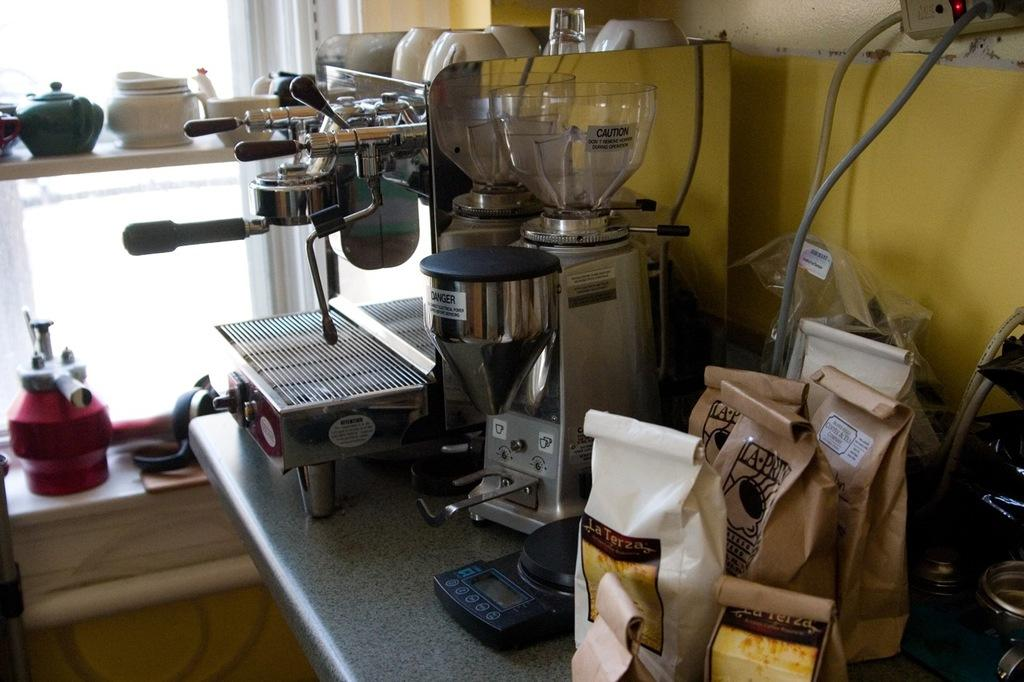Provide a one-sentence caption for the provided image. A white bag with La Terza sits on a table next to coffee makers. 